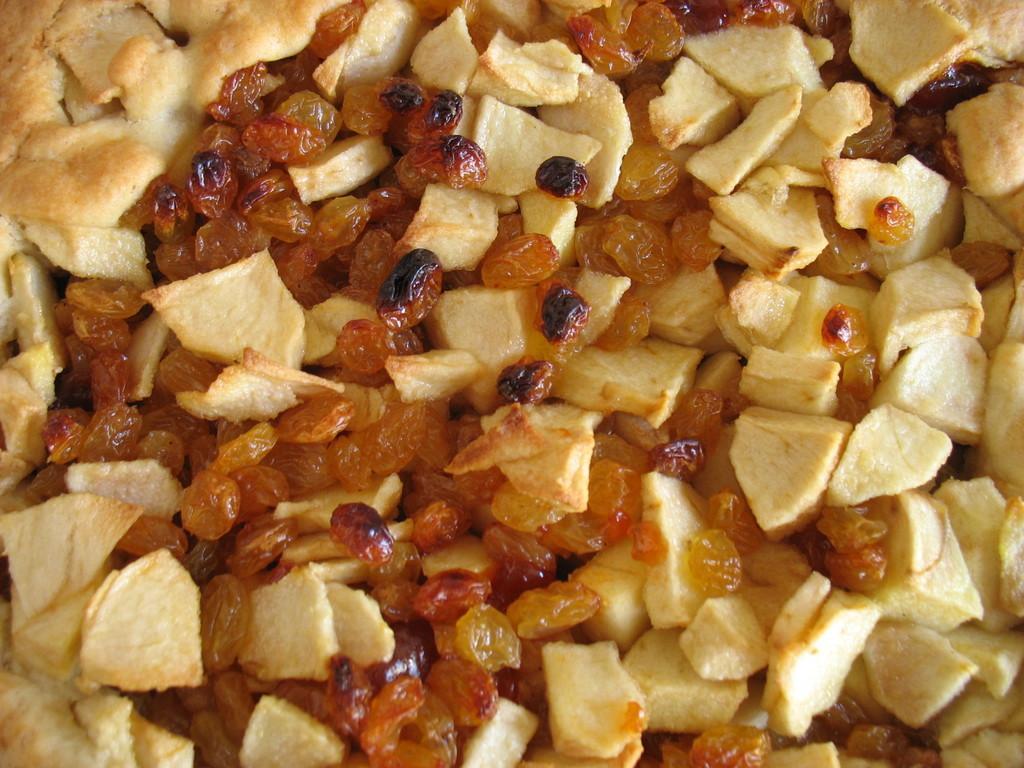Could you give a brief overview of what you see in this image? In this image I can see different types of food. I can see colour of these food are brown and yellow. 